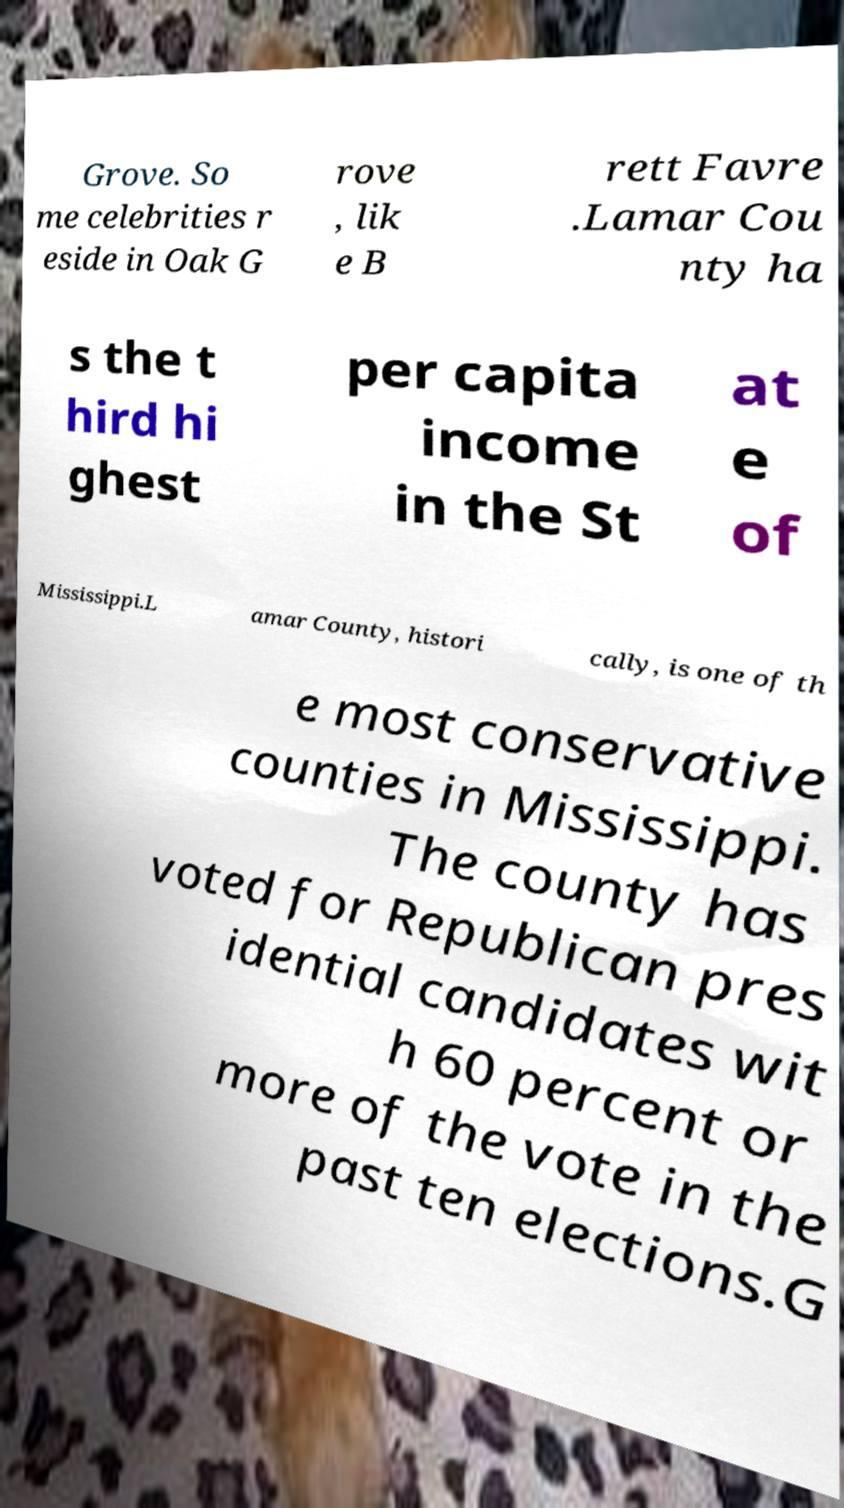Please read and relay the text visible in this image. What does it say? Grove. So me celebrities r eside in Oak G rove , lik e B rett Favre .Lamar Cou nty ha s the t hird hi ghest per capita income in the St at e of Mississippi.L amar County, histori cally, is one of th e most conservative counties in Mississippi. The county has voted for Republican pres idential candidates wit h 60 percent or more of the vote in the past ten elections.G 